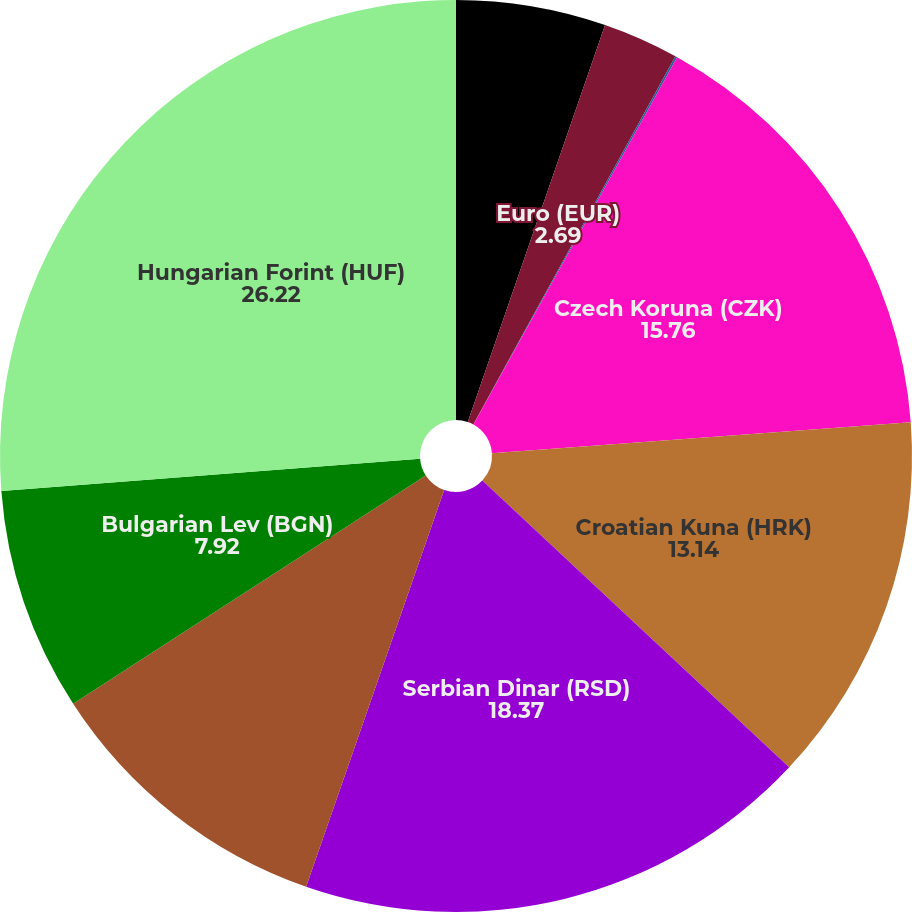Convert chart. <chart><loc_0><loc_0><loc_500><loc_500><pie_chart><fcel>Canadian dollar (CAD)<fcel>Euro (EUR)<fcel>British pound (GBP)<fcel>Czech Koruna (CZK)<fcel>Croatian Kuna (HRK)<fcel>Serbian Dinar (RSD)<fcel>Romanian Leu (RON)<fcel>Bulgarian Lev (BGN)<fcel>Hungarian Forint (HUF)<nl><fcel>5.3%<fcel>2.69%<fcel>0.07%<fcel>15.76%<fcel>13.14%<fcel>18.37%<fcel>10.53%<fcel>7.92%<fcel>26.22%<nl></chart> 